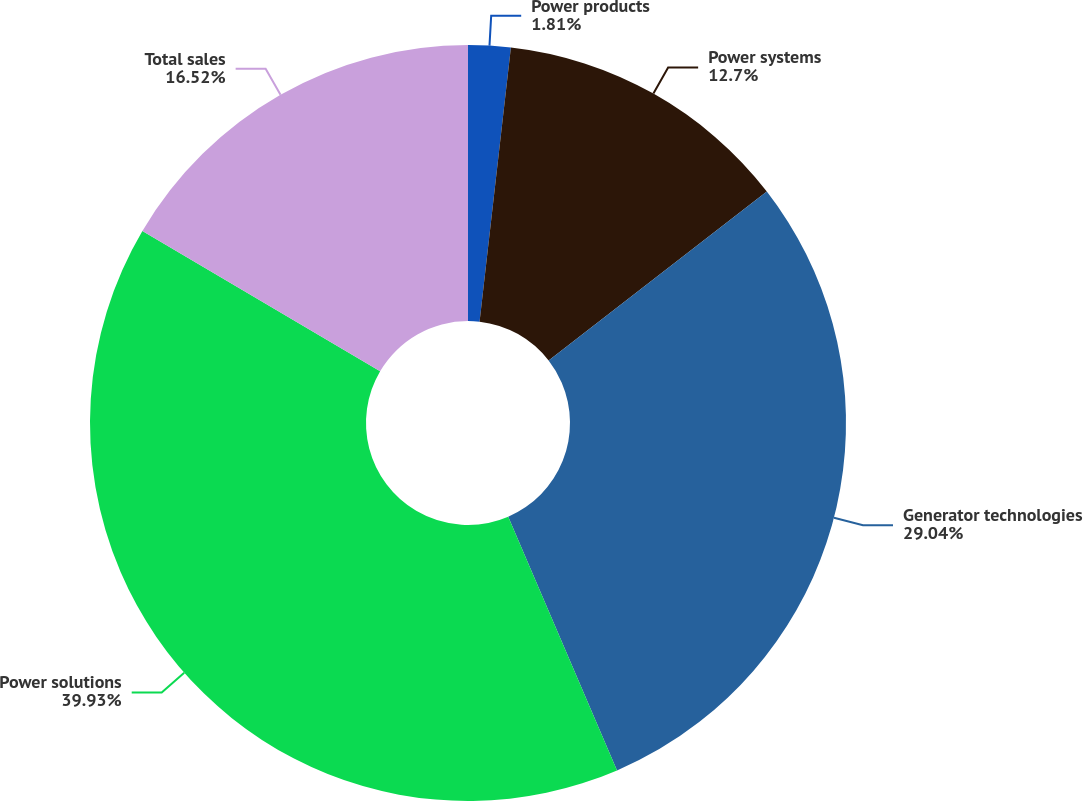Convert chart to OTSL. <chart><loc_0><loc_0><loc_500><loc_500><pie_chart><fcel>Power products<fcel>Power systems<fcel>Generator technologies<fcel>Power solutions<fcel>Total sales<nl><fcel>1.81%<fcel>12.7%<fcel>29.04%<fcel>39.93%<fcel>16.52%<nl></chart> 